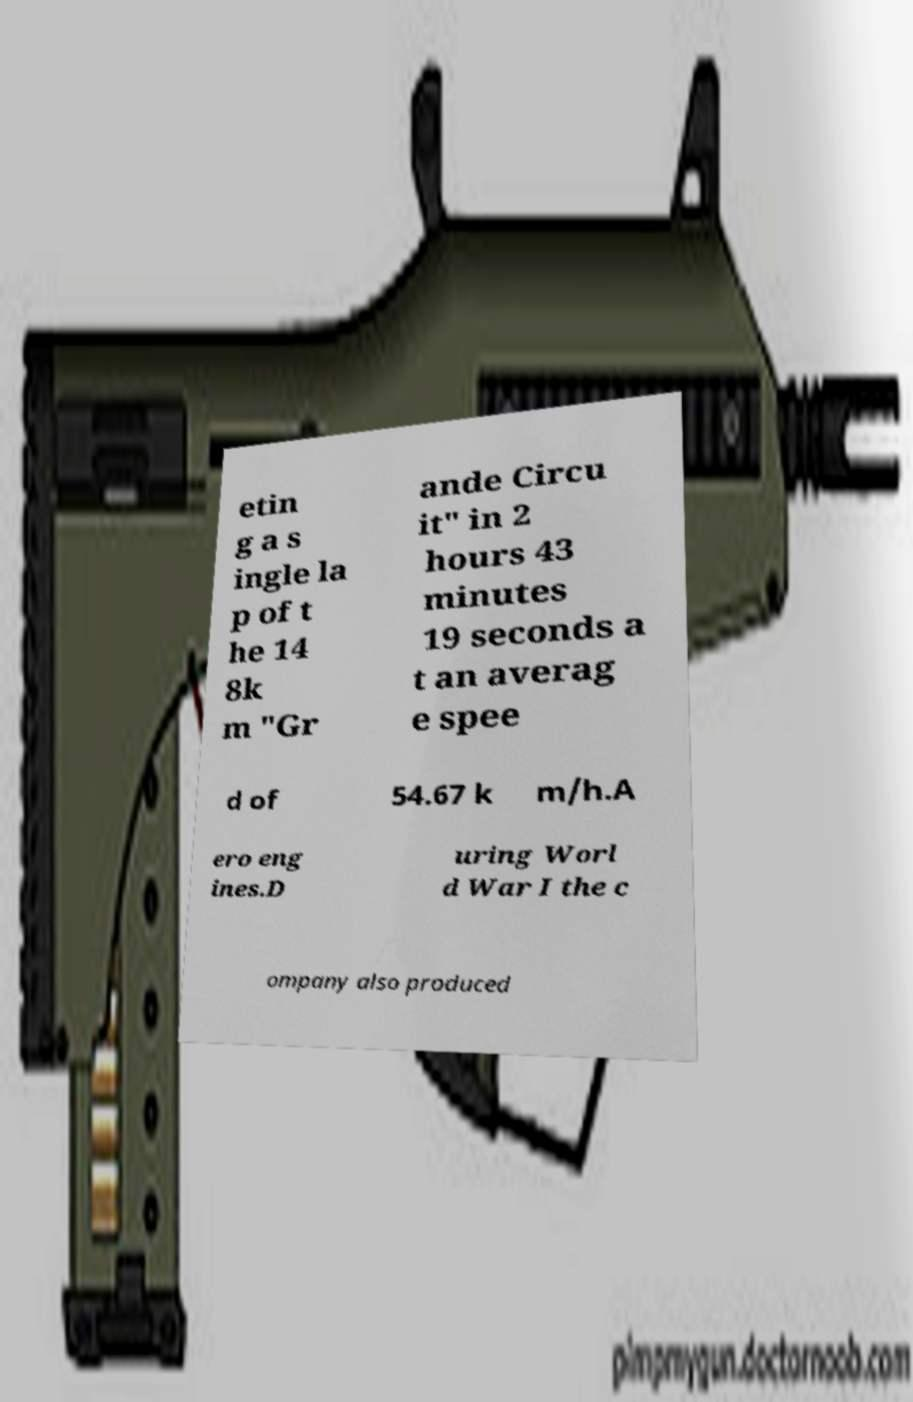Can you accurately transcribe the text from the provided image for me? etin g a s ingle la p of t he 14 8k m "Gr ande Circu it" in 2 hours 43 minutes 19 seconds a t an averag e spee d of 54.67 k m/h.A ero eng ines.D uring Worl d War I the c ompany also produced 